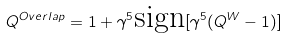Convert formula to latex. <formula><loc_0><loc_0><loc_500><loc_500>Q ^ { O v e r l a p } = 1 + \gamma ^ { 5 } \text {sign} [ \gamma ^ { 5 } ( Q ^ { W } - 1 ) ]</formula> 